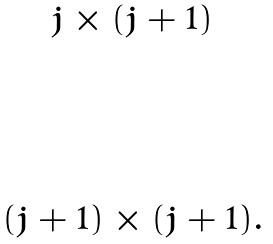Convert formula to latex. <formula><loc_0><loc_0><loc_500><loc_500>\begin{matrix} j \times ( j + 1 ) \\ \\ \\ \\ \\ ( j + 1 ) \times ( j + 1 ) . \end{matrix}</formula> 